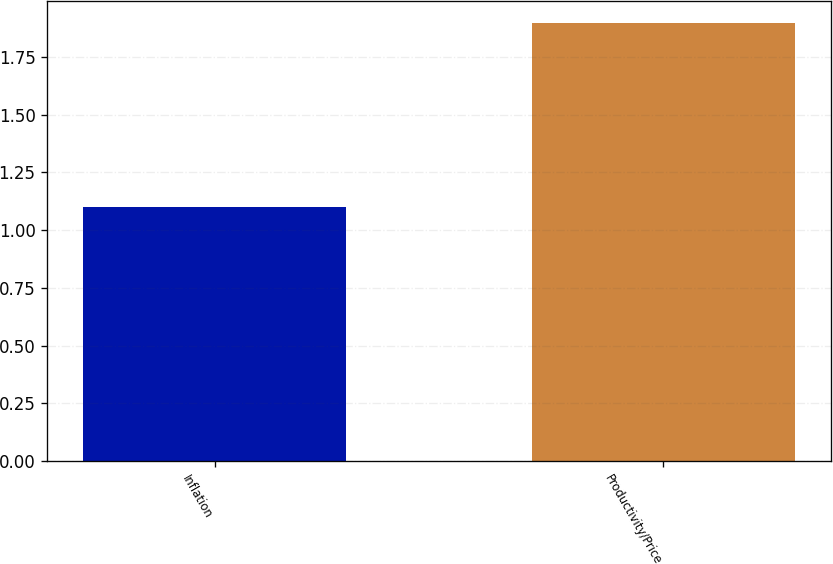<chart> <loc_0><loc_0><loc_500><loc_500><bar_chart><fcel>Inflation<fcel>Productivity/Price<nl><fcel>1.1<fcel>1.9<nl></chart> 